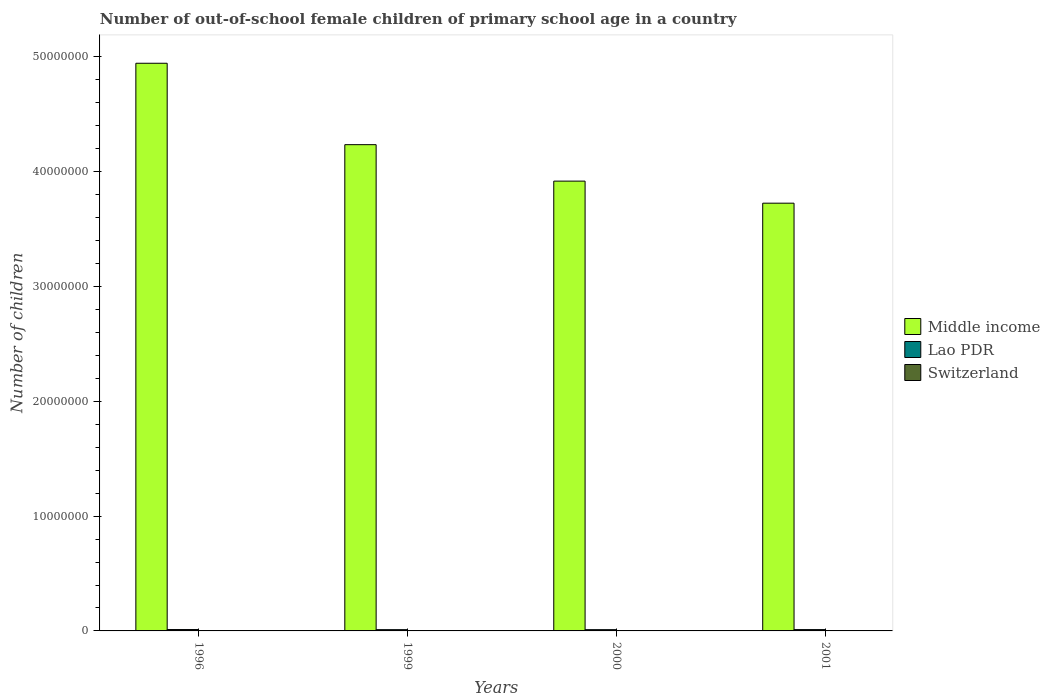Are the number of bars per tick equal to the number of legend labels?
Provide a short and direct response. Yes. Are the number of bars on each tick of the X-axis equal?
Your answer should be compact. Yes. What is the number of out-of-school female children in Switzerland in 1999?
Offer a very short reply. 749. Across all years, what is the maximum number of out-of-school female children in Middle income?
Give a very brief answer. 4.95e+07. Across all years, what is the minimum number of out-of-school female children in Switzerland?
Keep it short and to the point. 600. In which year was the number of out-of-school female children in Switzerland minimum?
Keep it short and to the point. 2001. What is the total number of out-of-school female children in Middle income in the graph?
Make the answer very short. 1.68e+08. What is the difference between the number of out-of-school female children in Switzerland in 1996 and that in 2000?
Keep it short and to the point. 2.12e+04. What is the difference between the number of out-of-school female children in Lao PDR in 2001 and the number of out-of-school female children in Switzerland in 1999?
Offer a terse response. 1.14e+05. What is the average number of out-of-school female children in Middle income per year?
Your answer should be compact. 4.21e+07. In the year 2001, what is the difference between the number of out-of-school female children in Lao PDR and number of out-of-school female children in Switzerland?
Provide a short and direct response. 1.14e+05. In how many years, is the number of out-of-school female children in Switzerland greater than 42000000?
Keep it short and to the point. 0. What is the ratio of the number of out-of-school female children in Switzerland in 1996 to that in 1999?
Keep it short and to the point. 29.25. Is the number of out-of-school female children in Lao PDR in 1996 less than that in 1999?
Your answer should be very brief. No. What is the difference between the highest and the second highest number of out-of-school female children in Middle income?
Your answer should be very brief. 7.09e+06. What is the difference between the highest and the lowest number of out-of-school female children in Lao PDR?
Keep it short and to the point. 1.20e+04. What does the 2nd bar from the left in 1996 represents?
Make the answer very short. Lao PDR. What does the 3rd bar from the right in 1996 represents?
Your answer should be very brief. Middle income. What is the difference between two consecutive major ticks on the Y-axis?
Make the answer very short. 1.00e+07. Are the values on the major ticks of Y-axis written in scientific E-notation?
Keep it short and to the point. No. Does the graph contain any zero values?
Your response must be concise. No. Does the graph contain grids?
Your answer should be very brief. No. How are the legend labels stacked?
Give a very brief answer. Vertical. What is the title of the graph?
Provide a short and direct response. Number of out-of-school female children of primary school age in a country. Does "Micronesia" appear as one of the legend labels in the graph?
Give a very brief answer. No. What is the label or title of the Y-axis?
Your response must be concise. Number of children. What is the Number of children in Middle income in 1996?
Offer a very short reply. 4.95e+07. What is the Number of children of Lao PDR in 1996?
Your response must be concise. 1.21e+05. What is the Number of children of Switzerland in 1996?
Provide a short and direct response. 2.19e+04. What is the Number of children in Middle income in 1999?
Give a very brief answer. 4.24e+07. What is the Number of children in Lao PDR in 1999?
Ensure brevity in your answer.  1.09e+05. What is the Number of children of Switzerland in 1999?
Offer a very short reply. 749. What is the Number of children of Middle income in 2000?
Make the answer very short. 3.92e+07. What is the Number of children of Lao PDR in 2000?
Make the answer very short. 1.10e+05. What is the Number of children of Switzerland in 2000?
Your answer should be compact. 745. What is the Number of children of Middle income in 2001?
Ensure brevity in your answer.  3.73e+07. What is the Number of children of Lao PDR in 2001?
Offer a terse response. 1.15e+05. What is the Number of children of Switzerland in 2001?
Your answer should be compact. 600. Across all years, what is the maximum Number of children in Middle income?
Provide a short and direct response. 4.95e+07. Across all years, what is the maximum Number of children in Lao PDR?
Give a very brief answer. 1.21e+05. Across all years, what is the maximum Number of children of Switzerland?
Your response must be concise. 2.19e+04. Across all years, what is the minimum Number of children of Middle income?
Provide a succinct answer. 3.73e+07. Across all years, what is the minimum Number of children in Lao PDR?
Give a very brief answer. 1.09e+05. Across all years, what is the minimum Number of children of Switzerland?
Offer a very short reply. 600. What is the total Number of children in Middle income in the graph?
Give a very brief answer. 1.68e+08. What is the total Number of children of Lao PDR in the graph?
Provide a succinct answer. 4.55e+05. What is the total Number of children in Switzerland in the graph?
Ensure brevity in your answer.  2.40e+04. What is the difference between the Number of children of Middle income in 1996 and that in 1999?
Your answer should be compact. 7.09e+06. What is the difference between the Number of children in Lao PDR in 1996 and that in 1999?
Ensure brevity in your answer.  1.20e+04. What is the difference between the Number of children of Switzerland in 1996 and that in 1999?
Give a very brief answer. 2.12e+04. What is the difference between the Number of children in Middle income in 1996 and that in 2000?
Offer a very short reply. 1.03e+07. What is the difference between the Number of children of Lao PDR in 1996 and that in 2000?
Provide a short and direct response. 1.12e+04. What is the difference between the Number of children in Switzerland in 1996 and that in 2000?
Provide a short and direct response. 2.12e+04. What is the difference between the Number of children of Middle income in 1996 and that in 2001?
Offer a very short reply. 1.22e+07. What is the difference between the Number of children of Lao PDR in 1996 and that in 2001?
Make the answer very short. 6118. What is the difference between the Number of children of Switzerland in 1996 and that in 2001?
Ensure brevity in your answer.  2.13e+04. What is the difference between the Number of children in Middle income in 1999 and that in 2000?
Offer a very short reply. 3.18e+06. What is the difference between the Number of children in Lao PDR in 1999 and that in 2000?
Provide a succinct answer. -736. What is the difference between the Number of children of Switzerland in 1999 and that in 2000?
Make the answer very short. 4. What is the difference between the Number of children in Middle income in 1999 and that in 2001?
Give a very brief answer. 5.10e+06. What is the difference between the Number of children of Lao PDR in 1999 and that in 2001?
Your answer should be very brief. -5841. What is the difference between the Number of children of Switzerland in 1999 and that in 2001?
Provide a short and direct response. 149. What is the difference between the Number of children in Middle income in 2000 and that in 2001?
Your answer should be compact. 1.92e+06. What is the difference between the Number of children in Lao PDR in 2000 and that in 2001?
Give a very brief answer. -5105. What is the difference between the Number of children in Switzerland in 2000 and that in 2001?
Offer a terse response. 145. What is the difference between the Number of children in Middle income in 1996 and the Number of children in Lao PDR in 1999?
Your answer should be very brief. 4.93e+07. What is the difference between the Number of children in Middle income in 1996 and the Number of children in Switzerland in 1999?
Offer a very short reply. 4.95e+07. What is the difference between the Number of children in Lao PDR in 1996 and the Number of children in Switzerland in 1999?
Ensure brevity in your answer.  1.20e+05. What is the difference between the Number of children of Middle income in 1996 and the Number of children of Lao PDR in 2000?
Your answer should be compact. 4.93e+07. What is the difference between the Number of children in Middle income in 1996 and the Number of children in Switzerland in 2000?
Provide a succinct answer. 4.95e+07. What is the difference between the Number of children of Lao PDR in 1996 and the Number of children of Switzerland in 2000?
Ensure brevity in your answer.  1.20e+05. What is the difference between the Number of children in Middle income in 1996 and the Number of children in Lao PDR in 2001?
Offer a very short reply. 4.93e+07. What is the difference between the Number of children in Middle income in 1996 and the Number of children in Switzerland in 2001?
Offer a very short reply. 4.95e+07. What is the difference between the Number of children in Lao PDR in 1996 and the Number of children in Switzerland in 2001?
Offer a terse response. 1.20e+05. What is the difference between the Number of children of Middle income in 1999 and the Number of children of Lao PDR in 2000?
Offer a very short reply. 4.23e+07. What is the difference between the Number of children of Middle income in 1999 and the Number of children of Switzerland in 2000?
Your answer should be very brief. 4.24e+07. What is the difference between the Number of children of Lao PDR in 1999 and the Number of children of Switzerland in 2000?
Offer a terse response. 1.08e+05. What is the difference between the Number of children in Middle income in 1999 and the Number of children in Lao PDR in 2001?
Keep it short and to the point. 4.22e+07. What is the difference between the Number of children in Middle income in 1999 and the Number of children in Switzerland in 2001?
Provide a short and direct response. 4.24e+07. What is the difference between the Number of children of Lao PDR in 1999 and the Number of children of Switzerland in 2001?
Your response must be concise. 1.09e+05. What is the difference between the Number of children of Middle income in 2000 and the Number of children of Lao PDR in 2001?
Your response must be concise. 3.91e+07. What is the difference between the Number of children in Middle income in 2000 and the Number of children in Switzerland in 2001?
Offer a very short reply. 3.92e+07. What is the difference between the Number of children of Lao PDR in 2000 and the Number of children of Switzerland in 2001?
Provide a succinct answer. 1.09e+05. What is the average Number of children in Middle income per year?
Give a very brief answer. 4.21e+07. What is the average Number of children of Lao PDR per year?
Your response must be concise. 1.14e+05. What is the average Number of children of Switzerland per year?
Ensure brevity in your answer.  5999.75. In the year 1996, what is the difference between the Number of children in Middle income and Number of children in Lao PDR?
Keep it short and to the point. 4.93e+07. In the year 1996, what is the difference between the Number of children of Middle income and Number of children of Switzerland?
Offer a very short reply. 4.94e+07. In the year 1996, what is the difference between the Number of children of Lao PDR and Number of children of Switzerland?
Provide a succinct answer. 9.92e+04. In the year 1999, what is the difference between the Number of children of Middle income and Number of children of Lao PDR?
Provide a short and direct response. 4.23e+07. In the year 1999, what is the difference between the Number of children of Middle income and Number of children of Switzerland?
Keep it short and to the point. 4.24e+07. In the year 1999, what is the difference between the Number of children in Lao PDR and Number of children in Switzerland?
Give a very brief answer. 1.08e+05. In the year 2000, what is the difference between the Number of children of Middle income and Number of children of Lao PDR?
Offer a terse response. 3.91e+07. In the year 2000, what is the difference between the Number of children in Middle income and Number of children in Switzerland?
Your response must be concise. 3.92e+07. In the year 2000, what is the difference between the Number of children of Lao PDR and Number of children of Switzerland?
Provide a short and direct response. 1.09e+05. In the year 2001, what is the difference between the Number of children in Middle income and Number of children in Lao PDR?
Make the answer very short. 3.71e+07. In the year 2001, what is the difference between the Number of children of Middle income and Number of children of Switzerland?
Keep it short and to the point. 3.73e+07. In the year 2001, what is the difference between the Number of children of Lao PDR and Number of children of Switzerland?
Your response must be concise. 1.14e+05. What is the ratio of the Number of children of Middle income in 1996 to that in 1999?
Your answer should be very brief. 1.17. What is the ratio of the Number of children in Lao PDR in 1996 to that in 1999?
Give a very brief answer. 1.11. What is the ratio of the Number of children of Switzerland in 1996 to that in 1999?
Your response must be concise. 29.25. What is the ratio of the Number of children of Middle income in 1996 to that in 2000?
Offer a very short reply. 1.26. What is the ratio of the Number of children of Lao PDR in 1996 to that in 2000?
Offer a very short reply. 1.1. What is the ratio of the Number of children in Switzerland in 1996 to that in 2000?
Provide a short and direct response. 29.4. What is the ratio of the Number of children in Middle income in 1996 to that in 2001?
Ensure brevity in your answer.  1.33. What is the ratio of the Number of children in Lao PDR in 1996 to that in 2001?
Your answer should be compact. 1.05. What is the ratio of the Number of children of Switzerland in 1996 to that in 2001?
Provide a succinct answer. 36.51. What is the ratio of the Number of children of Middle income in 1999 to that in 2000?
Keep it short and to the point. 1.08. What is the ratio of the Number of children of Switzerland in 1999 to that in 2000?
Your answer should be compact. 1.01. What is the ratio of the Number of children in Middle income in 1999 to that in 2001?
Make the answer very short. 1.14. What is the ratio of the Number of children in Lao PDR in 1999 to that in 2001?
Keep it short and to the point. 0.95. What is the ratio of the Number of children in Switzerland in 1999 to that in 2001?
Ensure brevity in your answer.  1.25. What is the ratio of the Number of children in Middle income in 2000 to that in 2001?
Give a very brief answer. 1.05. What is the ratio of the Number of children of Lao PDR in 2000 to that in 2001?
Your answer should be compact. 0.96. What is the ratio of the Number of children in Switzerland in 2000 to that in 2001?
Provide a succinct answer. 1.24. What is the difference between the highest and the second highest Number of children in Middle income?
Your response must be concise. 7.09e+06. What is the difference between the highest and the second highest Number of children of Lao PDR?
Offer a very short reply. 6118. What is the difference between the highest and the second highest Number of children of Switzerland?
Keep it short and to the point. 2.12e+04. What is the difference between the highest and the lowest Number of children in Middle income?
Your answer should be very brief. 1.22e+07. What is the difference between the highest and the lowest Number of children of Lao PDR?
Offer a very short reply. 1.20e+04. What is the difference between the highest and the lowest Number of children of Switzerland?
Your answer should be compact. 2.13e+04. 